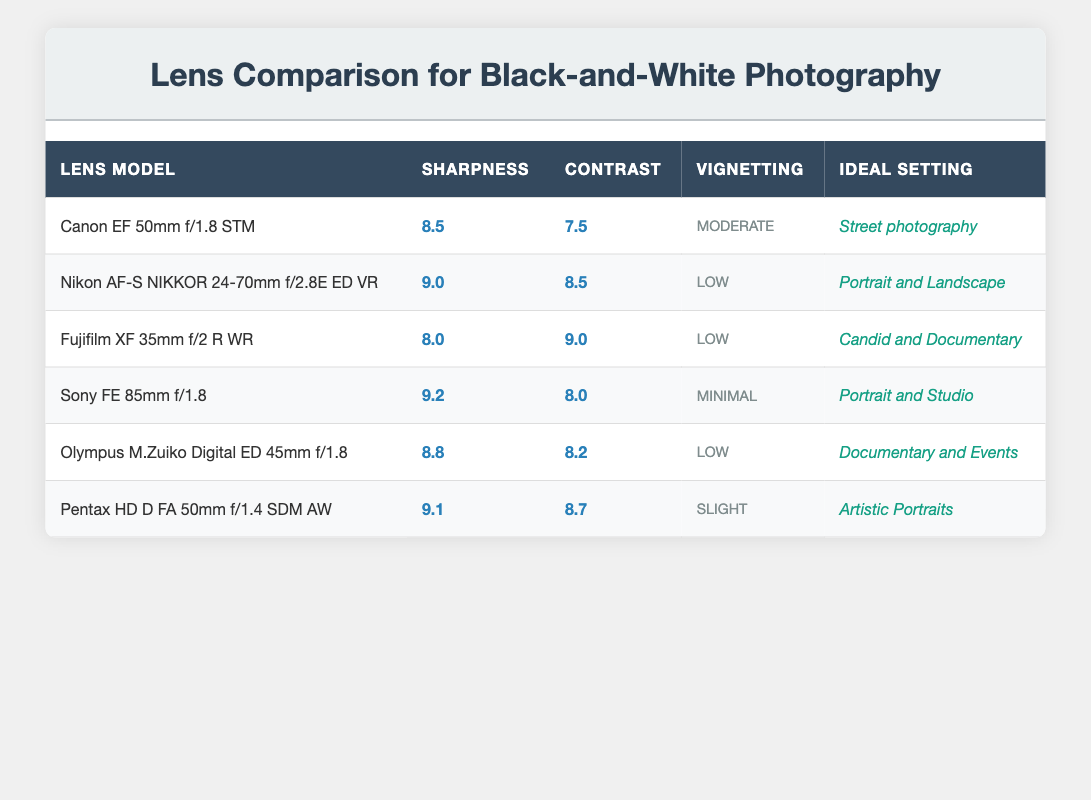What is the sharpness rating of the Sony FE 85mm f/1.8 lens? The table shows the sharpness rating for each lens model, and specifically for the Sony FE 85mm f/1.8 lens, the rating is directly stated as 9.2.
Answer: 9.2 Which lens has the highest contrast rating? By comparing the contrast ratings listed in the table, the highest rating is found for the Fujifilm XF 35mm f/2 R WR, which has a contrast rating of 9.0.
Answer: Fujifilm XF 35mm f/2 R WR What is the average sharpness rating of all the lenses listed? To calculate the average sharpness rating, we first sum the sharpness ratings: 8.5 + 9.0 + 8.0 + 9.2 + 8.8 + 9.1 = 52.6. There are 6 lenses, so we divide the total by 6: 52.6 / 6 = 8.767.
Answer: 8.77 Is the vignetting for the Nikon AF-S NIKKOR 24-70mm f/2.8E ED VR lens low? In the table, the vignetting for this lens is specified as "Low," indicating that it experiences minimal vignetting effects.
Answer: Yes Which lens is ideal for street photography, and what is its sharpness rating? The table indicates that the Canon EF 50mm f/1.8 STM lens is ideal for street photography, and its sharpness rating is 8.5.
Answer: Canon EF 50mm f/1.8 STM, 8.5 What is the difference in sharpness rating between the Nikon AF-S NIKKOR 24-70mm f/2.8E ED VR and the Olympus M.Zuiko Digital ED 45mm f/1.8 lenses? The sharpness rating for the Nikon lens is 9.0, while for the Olympus lens it is 8.8. To find the difference, subtract the lower rating from the higher one: 9.0 - 8.8 = 0.2.
Answer: 0.2 Which lens has the ideal setting for candid and documentary photography, and what is its rating for contrast? The Fujifilm XF 35mm f/2 R WR lens is stated as ideal for candid and documentary photography in the table; its contrast rating is 9.0.
Answer: Fujifilm XF 35mm f/2 R WR, 9.0 Are there any lenses listed with a sharpness rating lower than 8.0? By looking at the table, all lenses have a sharpness rating of 8.0 or higher, with none listed below that value.
Answer: No What lens would be best suited for artistic portraits based on sharpness and contrast ratings? The Pentax HD D FA 50mm f/1.4 SDM AW lens is rated 9.1 for sharpness and 8.7 for contrast, making it an excellent choice for artistic portraits according to the ratings in the table.
Answer: Pentax HD D FA 50mm f/1.4 SDM AW 